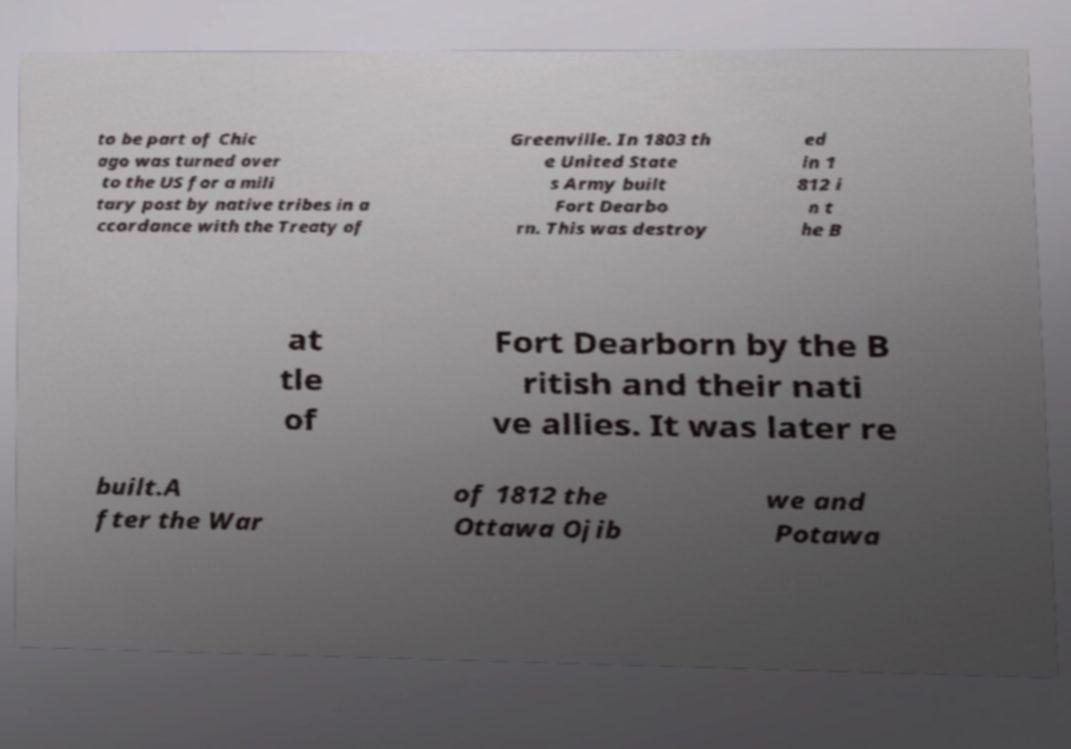I need the written content from this picture converted into text. Can you do that? to be part of Chic ago was turned over to the US for a mili tary post by native tribes in a ccordance with the Treaty of Greenville. In 1803 th e United State s Army built Fort Dearbo rn. This was destroy ed in 1 812 i n t he B at tle of Fort Dearborn by the B ritish and their nati ve allies. It was later re built.A fter the War of 1812 the Ottawa Ojib we and Potawa 